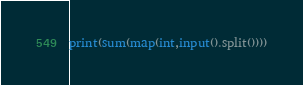Convert code to text. <code><loc_0><loc_0><loc_500><loc_500><_Python_>print(sum(map(int,input().split())))
</code> 